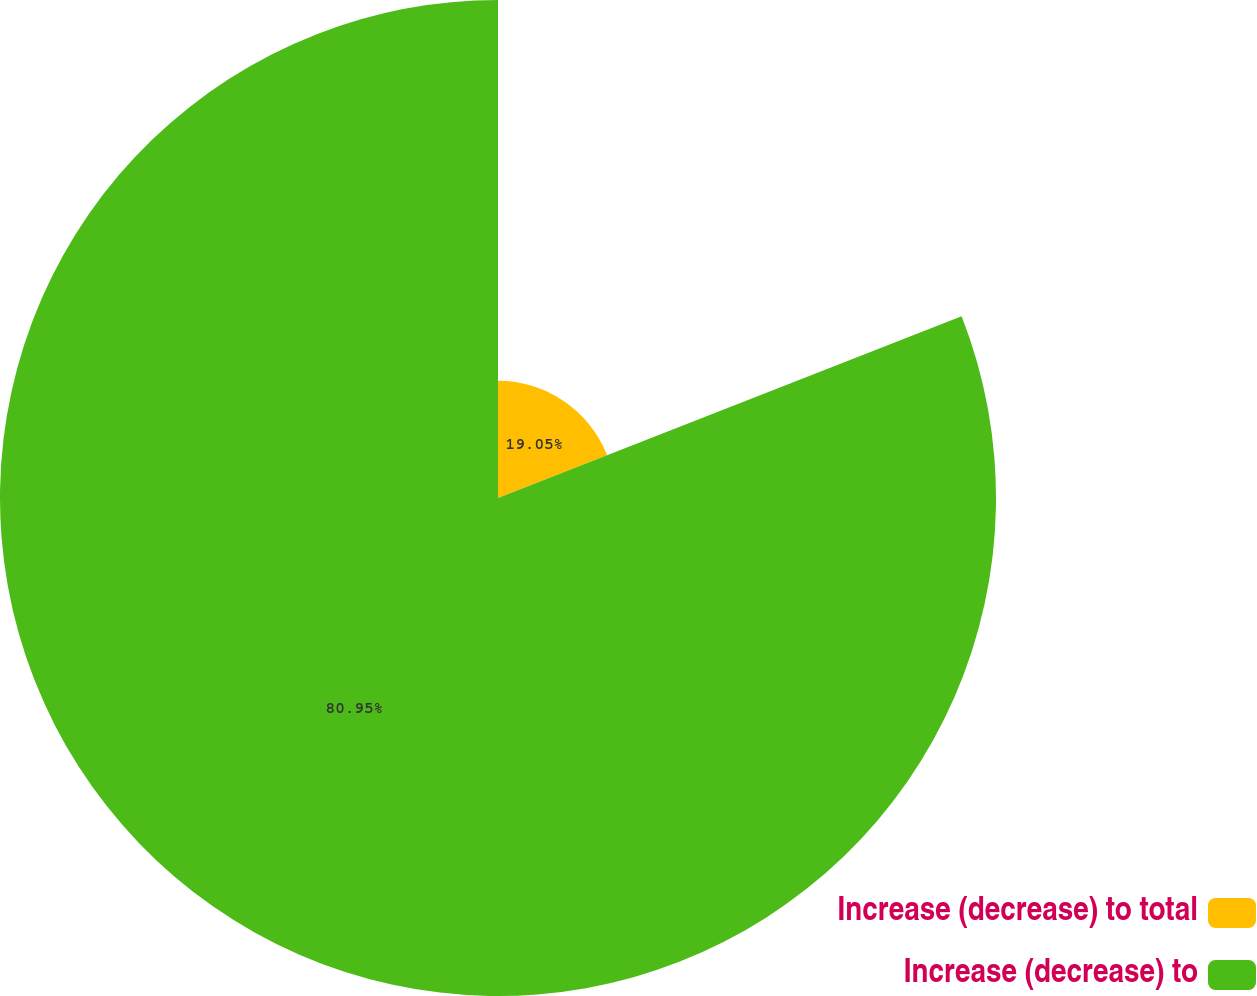<chart> <loc_0><loc_0><loc_500><loc_500><pie_chart><fcel>Increase (decrease) to total<fcel>Increase (decrease) to<nl><fcel>19.05%<fcel>80.95%<nl></chart> 